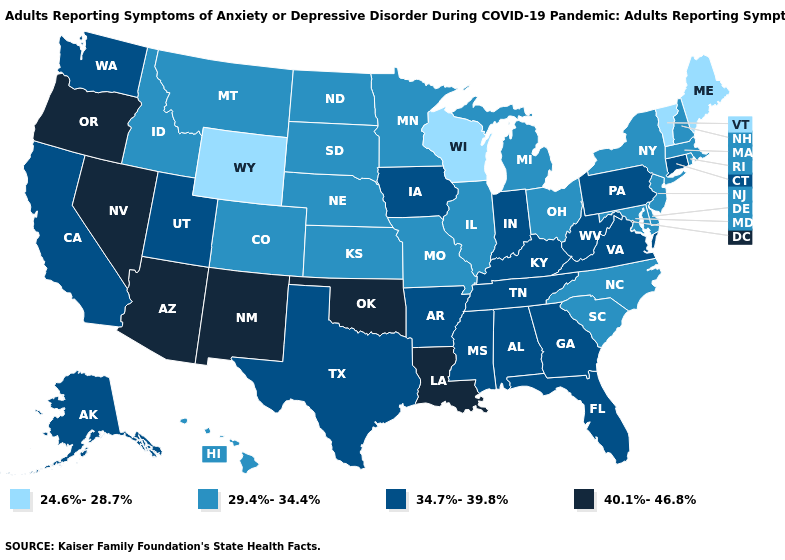Is the legend a continuous bar?
Keep it brief. No. What is the highest value in the USA?
Answer briefly. 40.1%-46.8%. Name the states that have a value in the range 24.6%-28.7%?
Give a very brief answer. Maine, Vermont, Wisconsin, Wyoming. What is the lowest value in the Northeast?
Quick response, please. 24.6%-28.7%. Name the states that have a value in the range 24.6%-28.7%?
Keep it brief. Maine, Vermont, Wisconsin, Wyoming. Name the states that have a value in the range 24.6%-28.7%?
Keep it brief. Maine, Vermont, Wisconsin, Wyoming. Which states have the lowest value in the USA?
Short answer required. Maine, Vermont, Wisconsin, Wyoming. What is the highest value in the USA?
Answer briefly. 40.1%-46.8%. What is the value of New York?
Concise answer only. 29.4%-34.4%. What is the highest value in states that border Wyoming?
Concise answer only. 34.7%-39.8%. Does the map have missing data?
Be succinct. No. Which states have the lowest value in the South?
Keep it brief. Delaware, Maryland, North Carolina, South Carolina. Does Florida have a lower value than Connecticut?
Answer briefly. No. Does Massachusetts have the lowest value in the Northeast?
Answer briefly. No. Name the states that have a value in the range 29.4%-34.4%?
Quick response, please. Colorado, Delaware, Hawaii, Idaho, Illinois, Kansas, Maryland, Massachusetts, Michigan, Minnesota, Missouri, Montana, Nebraska, New Hampshire, New Jersey, New York, North Carolina, North Dakota, Ohio, Rhode Island, South Carolina, South Dakota. 